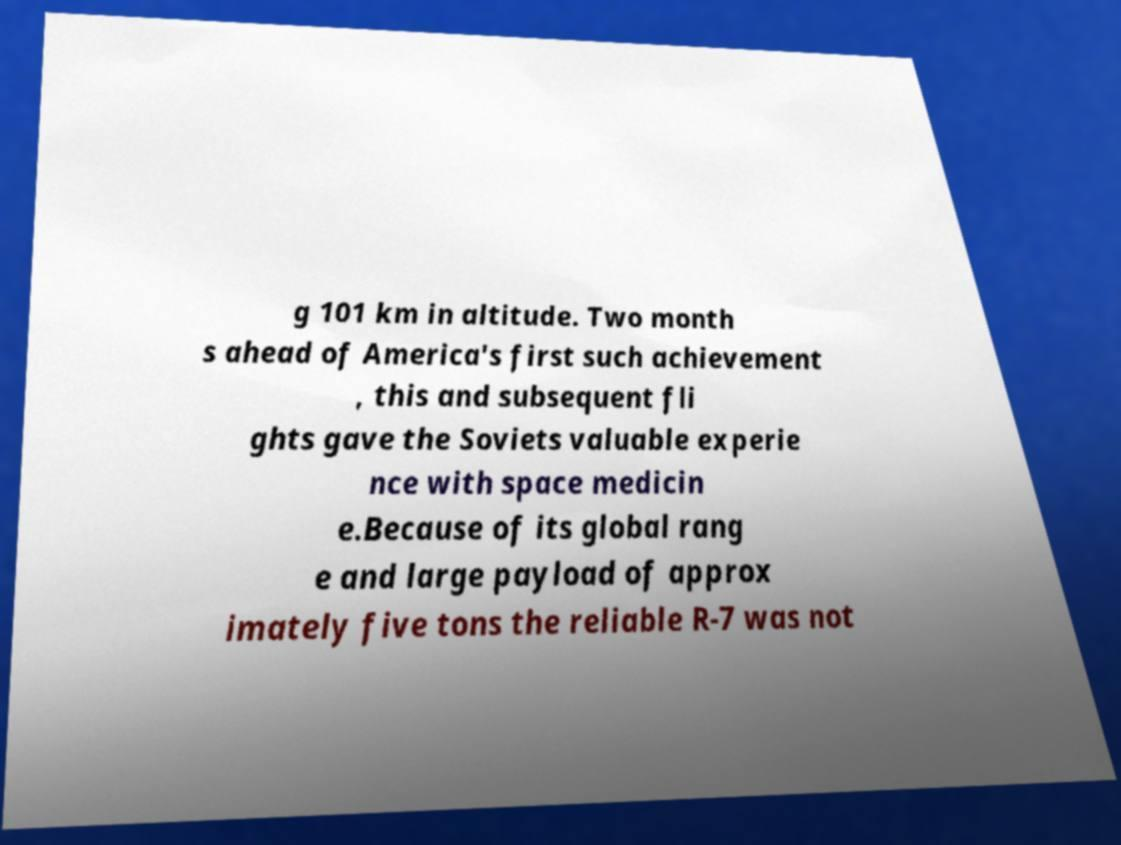Could you assist in decoding the text presented in this image and type it out clearly? g 101 km in altitude. Two month s ahead of America's first such achievement , this and subsequent fli ghts gave the Soviets valuable experie nce with space medicin e.Because of its global rang e and large payload of approx imately five tons the reliable R-7 was not 